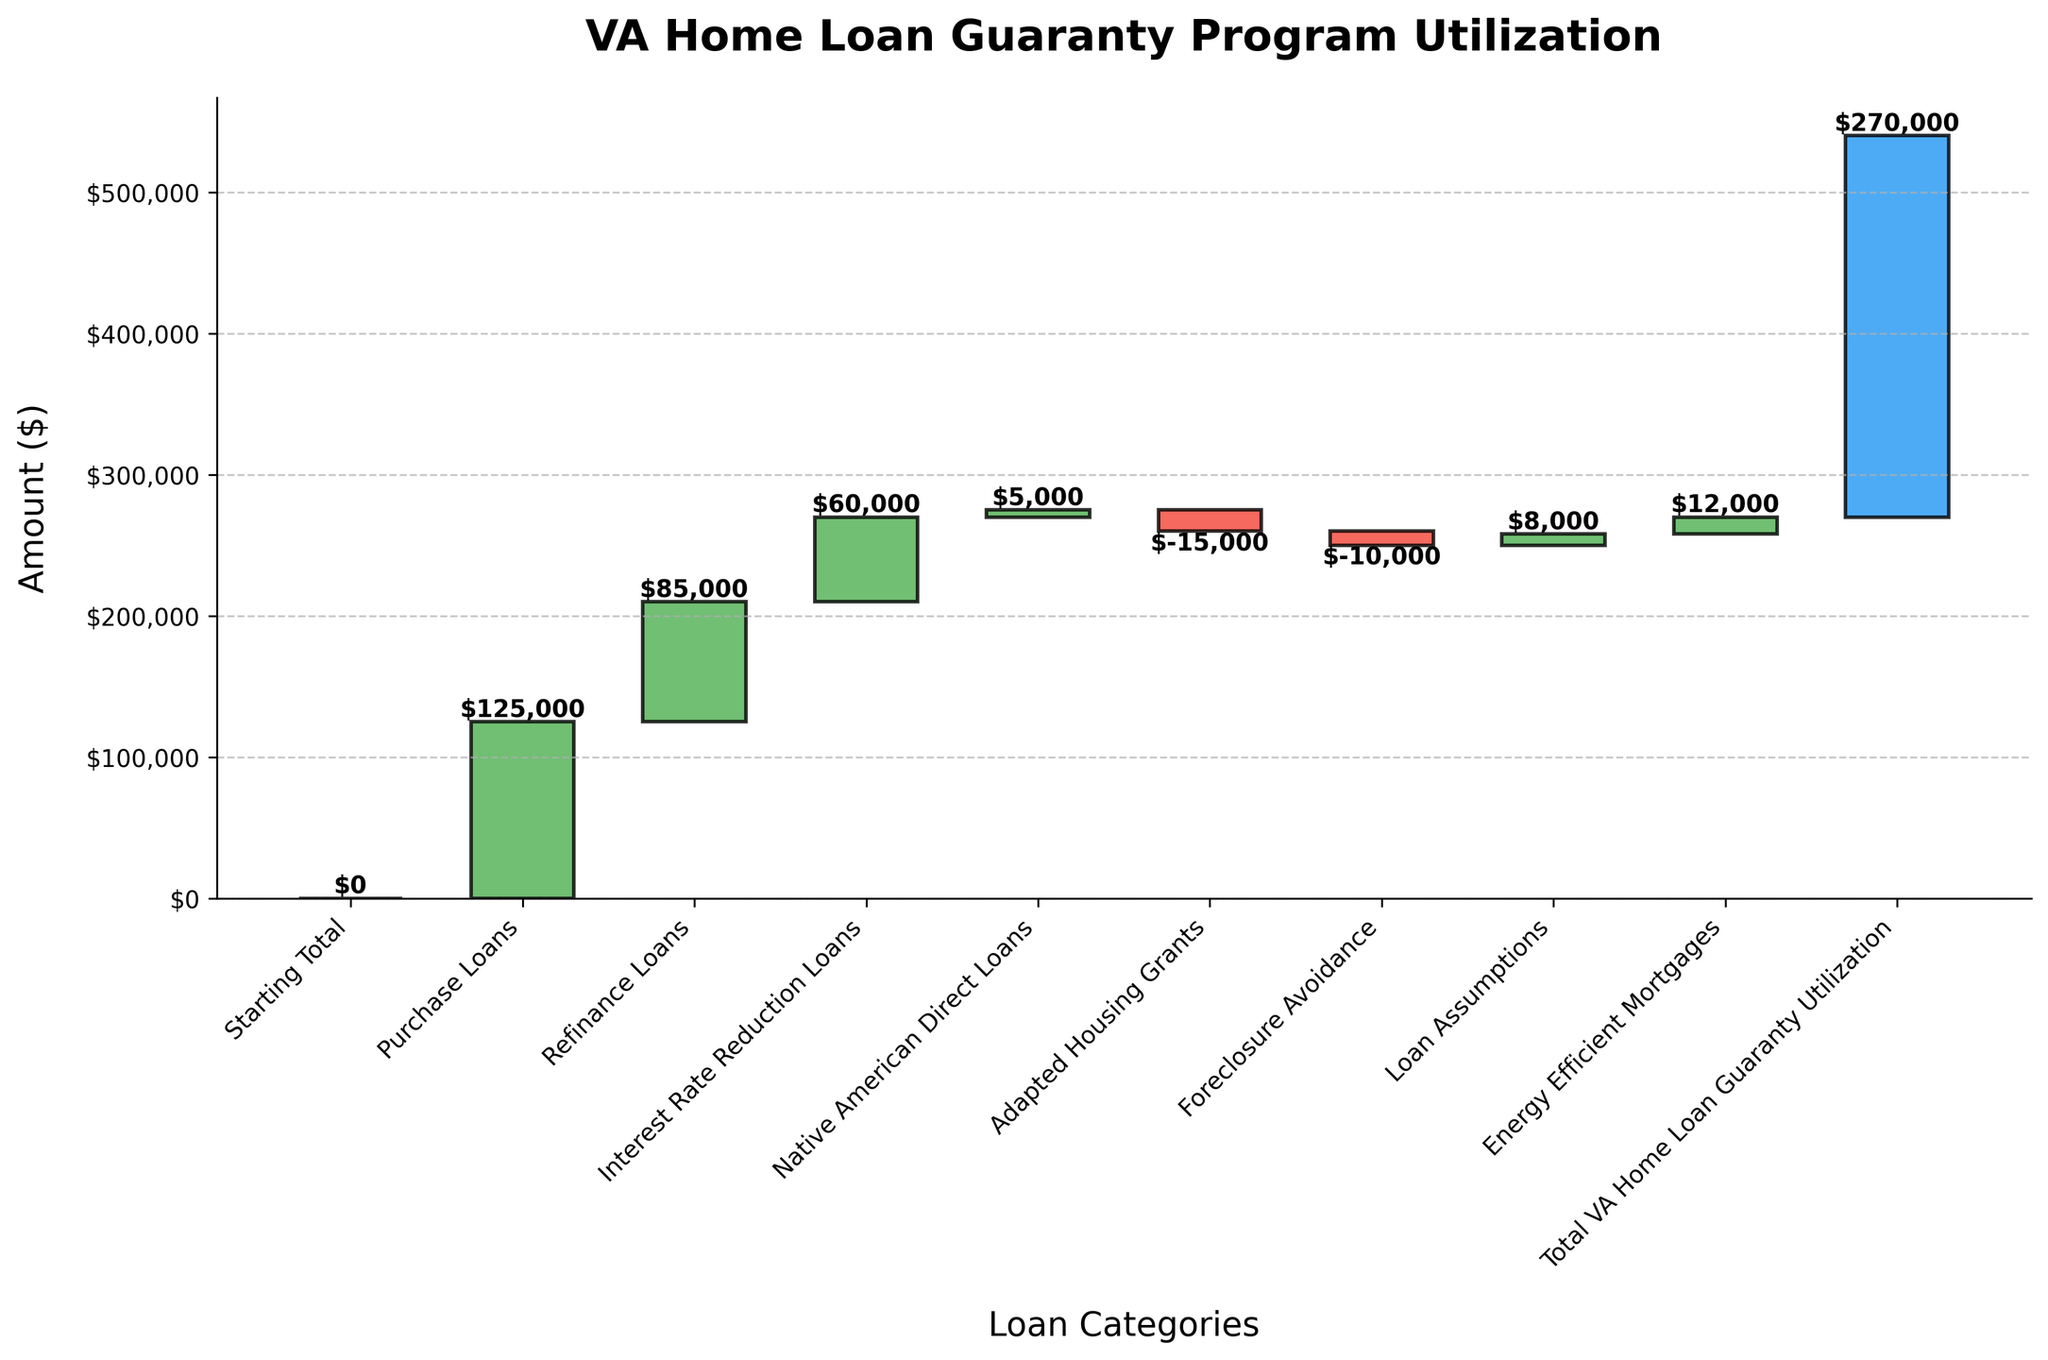What's the title of the chart? The title of the chart is usually located at the top, centered, and in bold text. In this case, it reads 'VA Home Loan Guaranty Program Utilization'.
Answer: 'VA Home Loan Guaranty Program Utilization' What is the total value of Purchase Loans? The value of Purchase Loans is directly shown on the second bar in the waterfall chart, labeled 'Purchase Loans'.
Answer: $125,000 Which category has the smallest utilization value, and what is it? By visual inspection, 'Adapted Housing Grants' has the smallest (negative) value. The label indicates it is -$15,000.
Answer: Adapted Housing Grants, -$15,000 What is the cumulative value after Refinance Loans? To find this, add 'Purchase Loans' and 'Refinance Loans' values: 125,000 + 85,000 = $210,000.
Answer: $210,000 How many categories have negative values? By visually inspecting the chart, 'Adapted Housing Grants' and 'Foreclosure Avoidance' have negative values. So, there are 2 such categories.
Answer: 2 What is the total VA home loan guaranty utilization? This is the sum represented by the last section of the waterfall chart, labeled as 'Total VA Home Loan Guaranty Utilization'.
Answer: $270,000 What is the difference between the values of Energy Efficient Mortgages and Loan Assumptions? The value of Energy Efficient Mortgages is $12,000 and that of Loan Assumptions is $8,000. Their difference is 12,000 - 8,000 = $4,000.
Answer: $4,000 Which has a higher cumulative value, Native American Direct Loans or Interest Rate Reduction Loans? Native American Direct Loans come after Interest Rate Reduction Loans in the cumulative sum. The cumulative value for Interest Rate Reduction Loans (310,000) is higher than just before Native American Direct Loans (315,000).
Answer: Interest Rate Reduction Loans What is the cumulative value at Energy Efficient Mortgages? Sum all the values up to and including 'Energy Efficient Mortgages': 125,000 + 85,000 + 60,000 + 5,000 + (-15,000) + (-10,000) + 8,000 + 12,000 = $270,000.
Answer: $270,000 How does the value of Foreclosure Avoidance compare to Native American Direct Loans? Visually, Foreclosure Avoidance has a negative value (-10,000) compared to the positive value of Native American Direct Loans (5,000). Therefore, Foreclosure Avoidance is less by 10,000 + 5,000 = 15,000.
Answer: Foreclosure Avoidance is $15,000 less 